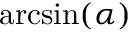<formula> <loc_0><loc_0><loc_500><loc_500>\arcsin ( \alpha )</formula> 